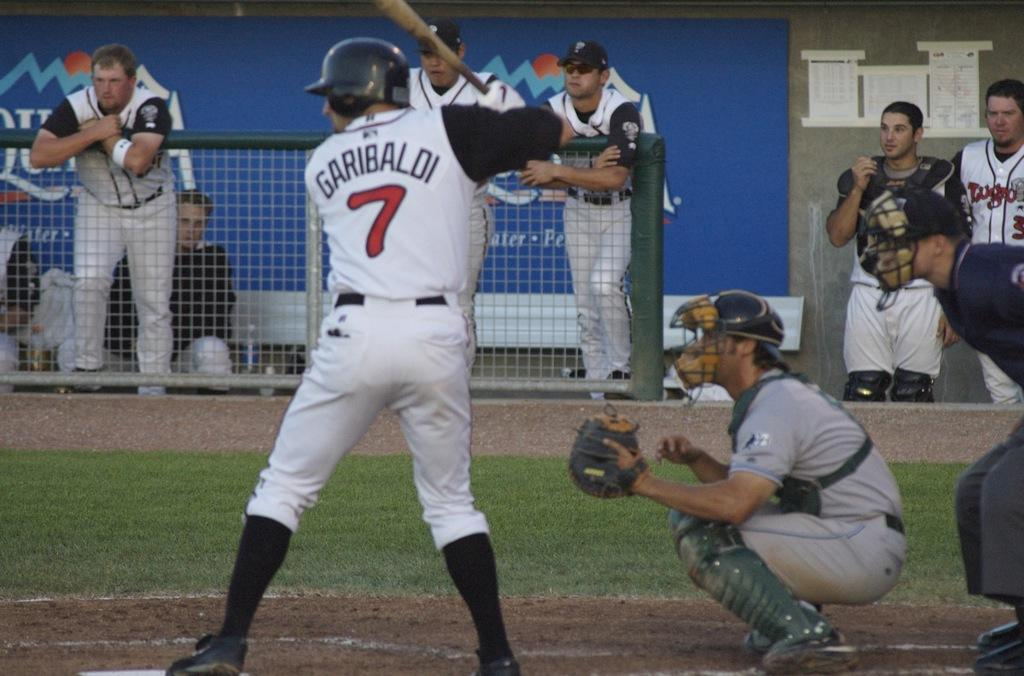<image>
Present a compact description of the photo's key features. Garibaldi #7 is up to bat, while the catcher crouches behind him. 